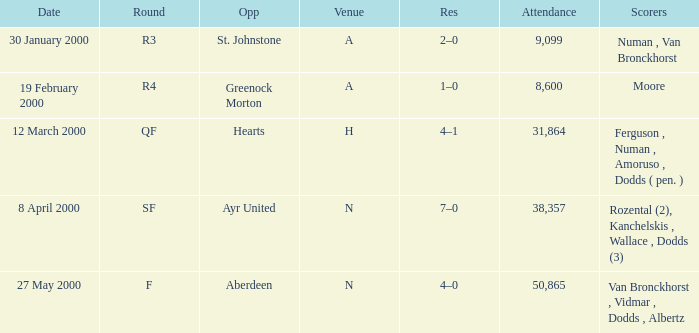What venue was on 27 May 2000? N. 